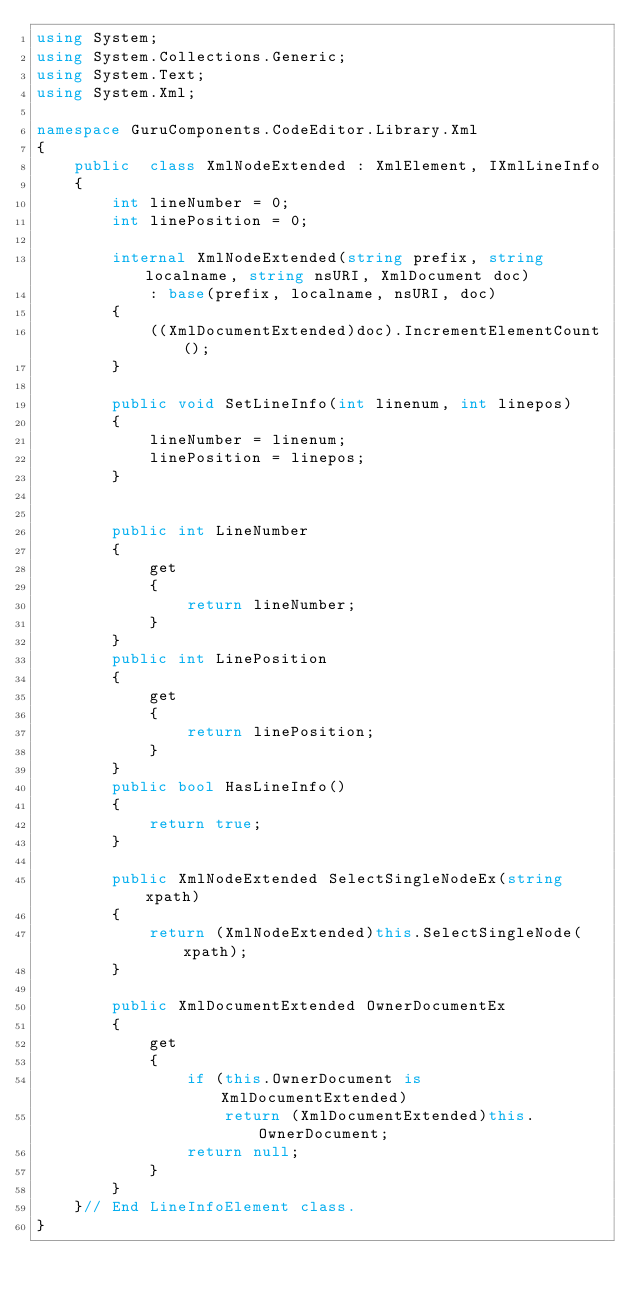Convert code to text. <code><loc_0><loc_0><loc_500><loc_500><_C#_>using System;
using System.Collections.Generic;
using System.Text;
using System.Xml;

namespace GuruComponents.CodeEditor.Library.Xml
{
    public  class XmlNodeExtended : XmlElement, IXmlLineInfo
    {
        int lineNumber = 0;
        int linePosition = 0;

        internal XmlNodeExtended(string prefix, string localname, string nsURI, XmlDocument doc)
            : base(prefix, localname, nsURI, doc)
        {
            ((XmlDocumentExtended)doc).IncrementElementCount();
        }

        public void SetLineInfo(int linenum, int linepos)
        {
            lineNumber = linenum;
            linePosition = linepos;
        }

   
        public int LineNumber
        {
            get
            {
                return lineNumber;
            }
        }
        public int LinePosition
        {
            get
            {
                return linePosition;
            }
        }
        public bool HasLineInfo()
        {
            return true;
        }

        public XmlNodeExtended SelectSingleNodeEx(string xpath)
        {
            return (XmlNodeExtended)this.SelectSingleNode(xpath);
        }

        public XmlDocumentExtended OwnerDocumentEx
        {
            get
            {
                if (this.OwnerDocument is XmlDocumentExtended)
                    return (XmlDocumentExtended)this.OwnerDocument;
                return null;
            }
        }
    }// End LineInfoElement class.
}
</code> 